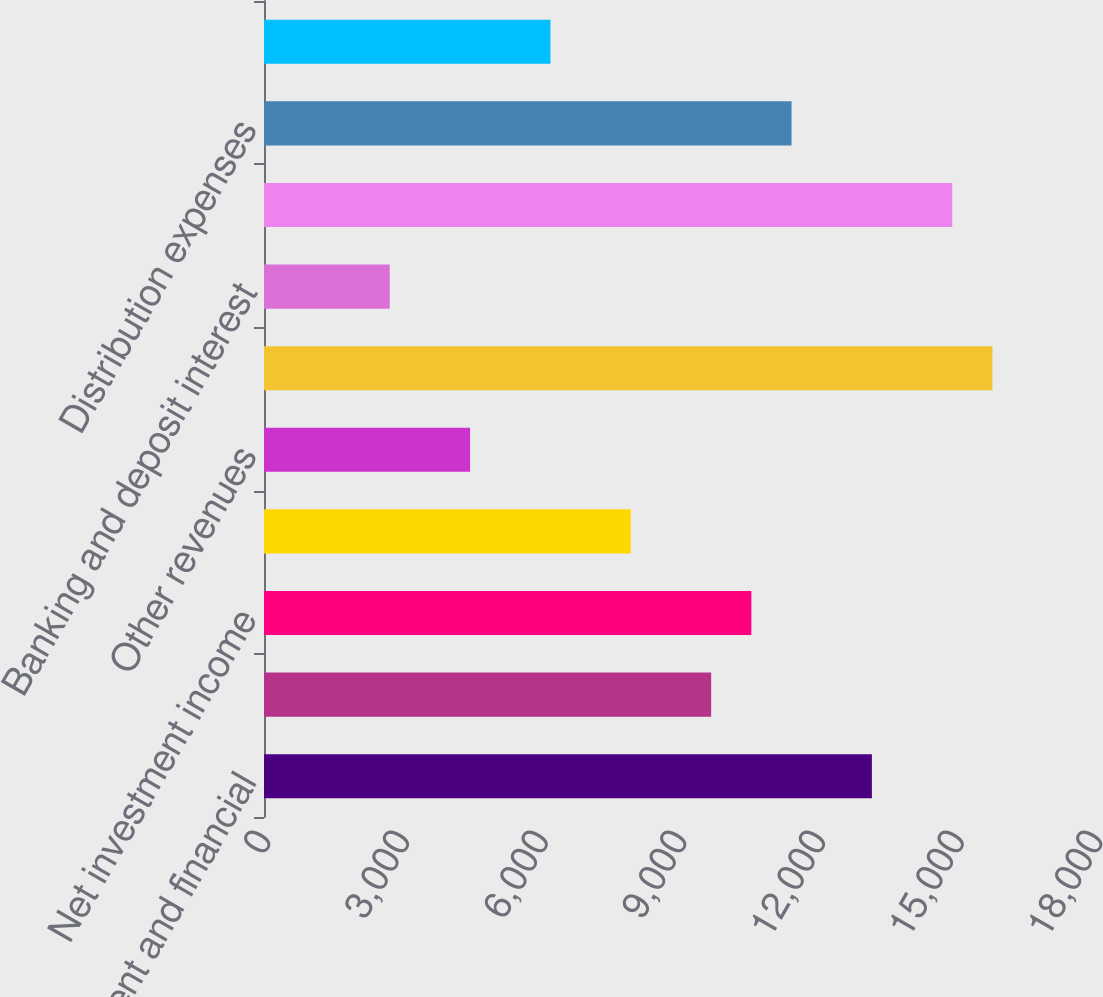Convert chart to OTSL. <chart><loc_0><loc_0><loc_500><loc_500><bar_chart><fcel>Management and financial<fcel>Distribution fees<fcel>Net investment income<fcel>Premiums<fcel>Other revenues<fcel>Total revenues<fcel>Banking and deposit interest<fcel>Total net revenues<fcel>Distribution expenses<fcel>Interest credited to fixed<nl><fcel>13151.5<fcel>9674.3<fcel>10543.6<fcel>7935.7<fcel>4458.5<fcel>15759.4<fcel>2719.9<fcel>14890.1<fcel>11412.9<fcel>6197.1<nl></chart> 